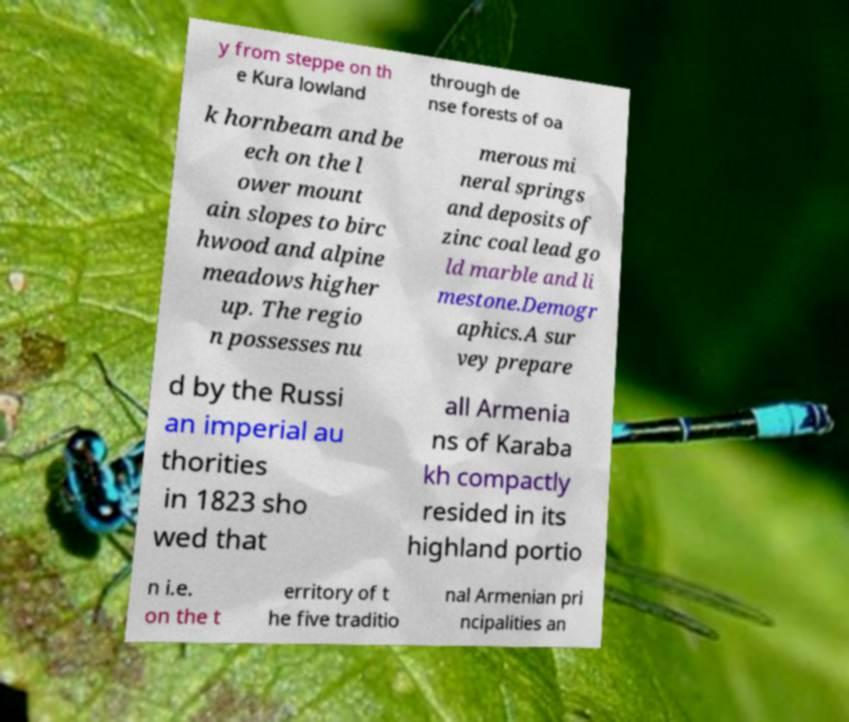Can you read and provide the text displayed in the image?This photo seems to have some interesting text. Can you extract and type it out for me? y from steppe on th e Kura lowland through de nse forests of oa k hornbeam and be ech on the l ower mount ain slopes to birc hwood and alpine meadows higher up. The regio n possesses nu merous mi neral springs and deposits of zinc coal lead go ld marble and li mestone.Demogr aphics.A sur vey prepare d by the Russi an imperial au thorities in 1823 sho wed that all Armenia ns of Karaba kh compactly resided in its highland portio n i.e. on the t erritory of t he five traditio nal Armenian pri ncipalities an 